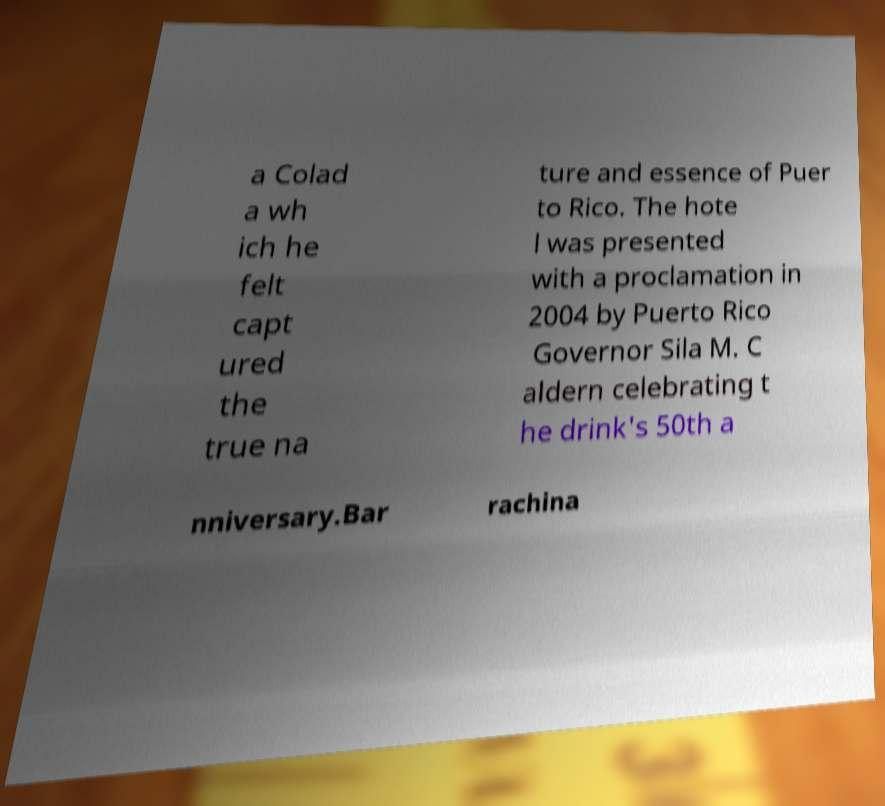I need the written content from this picture converted into text. Can you do that? a Colad a wh ich he felt capt ured the true na ture and essence of Puer to Rico. The hote l was presented with a proclamation in 2004 by Puerto Rico Governor Sila M. C aldern celebrating t he drink's 50th a nniversary.Bar rachina 